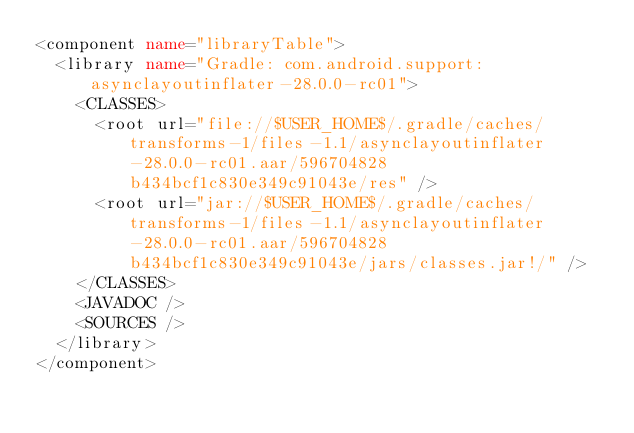Convert code to text. <code><loc_0><loc_0><loc_500><loc_500><_XML_><component name="libraryTable">
  <library name="Gradle: com.android.support:asynclayoutinflater-28.0.0-rc01">
    <CLASSES>
      <root url="file://$USER_HOME$/.gradle/caches/transforms-1/files-1.1/asynclayoutinflater-28.0.0-rc01.aar/596704828b434bcf1c830e349c91043e/res" />
      <root url="jar://$USER_HOME$/.gradle/caches/transforms-1/files-1.1/asynclayoutinflater-28.0.0-rc01.aar/596704828b434bcf1c830e349c91043e/jars/classes.jar!/" />
    </CLASSES>
    <JAVADOC />
    <SOURCES />
  </library>
</component></code> 